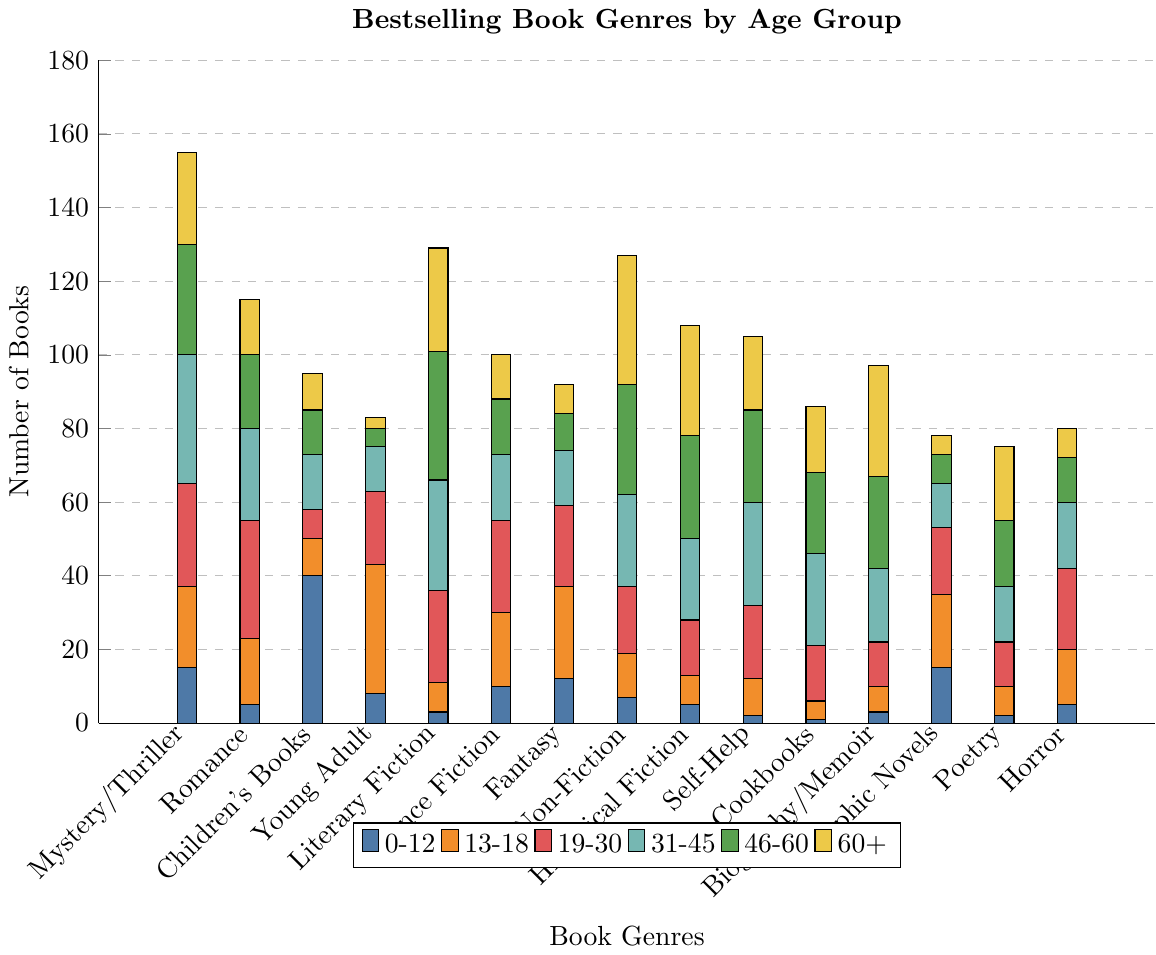Which genre is the most popular among 0-12 age group? To find the most popular genre among 0-12 age group, we look for the bar with the greatest height corresponding to this age group. The genre with the highest bar is "Children's Books" at 40 books.
Answer: Children's Books Which age group reads the most Mystery/Thriller books? We need to compare the heights of the bars of Mystery/Thriller genre across all age groups. The 31-45 age group has the tallest bar at 35 books.
Answer: 31-45 Which genre has the broadest appeal across all age groups? To determine which genre has broad appeal, observe the height of the bars across all age groups. The genre with relatively high bars in most age groups is "Mystery/Thriller".
Answer: Mystery/Thriller What is the sum of books sold in the Romance genre for the age groups 19-30 and 31-45? Add the number of books in the Romance genre for the age groups 19-30 and 31-45. For ages 19-30: 32 books, and for ages 31-45: 25 books. Summing them, 32 + 25 = 57 books.
Answer: 57 Which age group shows significant interest in Fantasy books besides 13-18? We compare the heights of the bars in the Fantasy genre. The highest bar apart from the 13-18 group (25) is the 19-30 group (22).
Answer: 19-30 How many more Non-Fiction books does the 60+ age group read compared to the 0-12 age group? Find the difference between the Non-Fiction books read by the 60+ and 0-12 age groups. For 60+: 35 books. For 0-12: 7 books. The difference is 35 - 7 = 28 books.
Answer: 28 Which genre has the least popularity in the 46-60 age group? We look for the shortest bar in the 46-60 age group, which is "Young Adult" with 5 books.
Answer: Young Adult What is the proportion of Literary Fiction books read by the 31-45 age group to the total number of Literary Fiction books sold? First, find the total Literary Fiction sales: 3 + 8 + 25 + 30 + 35 + 28 = 129 books. Then find the proportion of 31-45 group: 30 / 129.
Answer: approximately 0.23 Which two age groups have equal interest in Picture Books? Comparing the lengths of bars for each age group in the Children’s Books genre. The 0-12 age group has 40 books and no other age group has equal numbers to this. No two age groups have equal numbers for Children’s Books.
Answer: None 